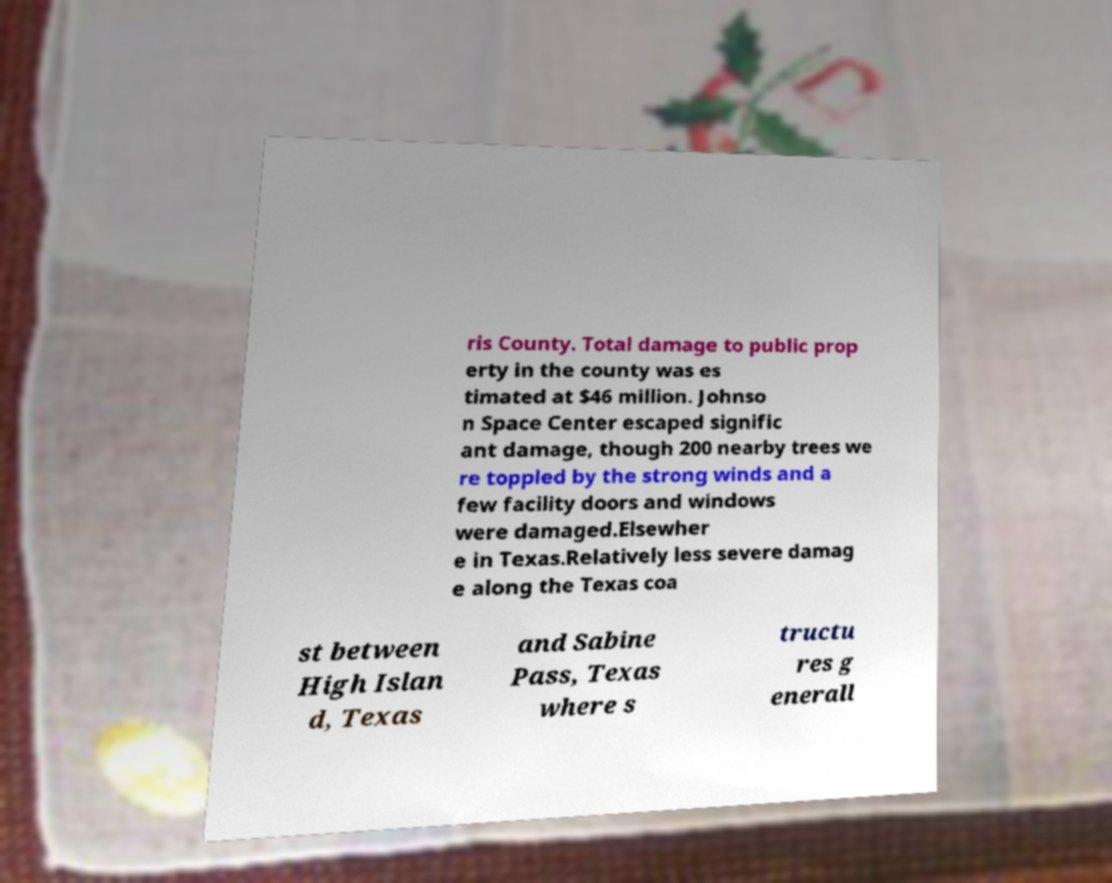Could you extract and type out the text from this image? ris County. Total damage to public prop erty in the county was es timated at $46 million. Johnso n Space Center escaped signific ant damage, though 200 nearby trees we re toppled by the strong winds and a few facility doors and windows were damaged.Elsewher e in Texas.Relatively less severe damag e along the Texas coa st between High Islan d, Texas and Sabine Pass, Texas where s tructu res g enerall 